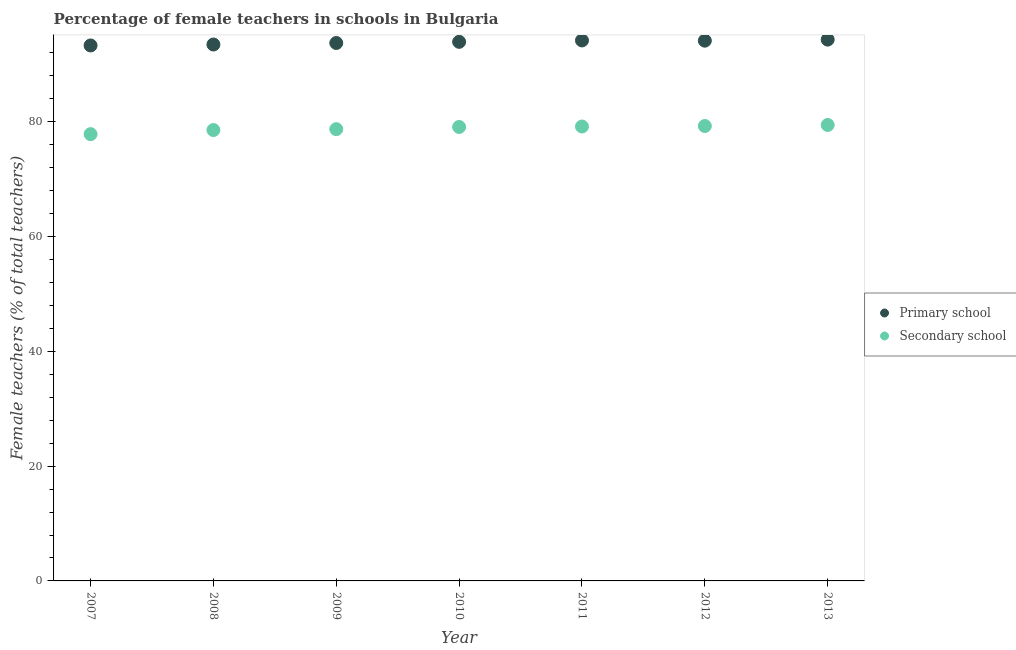How many different coloured dotlines are there?
Give a very brief answer. 2. Is the number of dotlines equal to the number of legend labels?
Provide a succinct answer. Yes. What is the percentage of female teachers in primary schools in 2009?
Keep it short and to the point. 93.73. Across all years, what is the maximum percentage of female teachers in secondary schools?
Give a very brief answer. 79.45. Across all years, what is the minimum percentage of female teachers in secondary schools?
Offer a terse response. 77.85. In which year was the percentage of female teachers in primary schools maximum?
Keep it short and to the point. 2013. In which year was the percentage of female teachers in primary schools minimum?
Give a very brief answer. 2007. What is the total percentage of female teachers in secondary schools in the graph?
Offer a very short reply. 552.12. What is the difference between the percentage of female teachers in primary schools in 2008 and that in 2010?
Offer a terse response. -0.47. What is the difference between the percentage of female teachers in primary schools in 2011 and the percentage of female teachers in secondary schools in 2009?
Your answer should be compact. 15.46. What is the average percentage of female teachers in secondary schools per year?
Make the answer very short. 78.87. In the year 2013, what is the difference between the percentage of female teachers in secondary schools and percentage of female teachers in primary schools?
Your response must be concise. -14.87. What is the ratio of the percentage of female teachers in primary schools in 2007 to that in 2010?
Your response must be concise. 0.99. What is the difference between the highest and the second highest percentage of female teachers in primary schools?
Offer a terse response. 0.15. What is the difference between the highest and the lowest percentage of female teachers in primary schools?
Make the answer very short. 1.02. In how many years, is the percentage of female teachers in secondary schools greater than the average percentage of female teachers in secondary schools taken over all years?
Keep it short and to the point. 4. Is the sum of the percentage of female teachers in secondary schools in 2009 and 2012 greater than the maximum percentage of female teachers in primary schools across all years?
Your answer should be very brief. Yes. Does the graph contain any zero values?
Offer a very short reply. No. Where does the legend appear in the graph?
Ensure brevity in your answer.  Center right. How many legend labels are there?
Give a very brief answer. 2. How are the legend labels stacked?
Offer a very short reply. Vertical. What is the title of the graph?
Give a very brief answer. Percentage of female teachers in schools in Bulgaria. What is the label or title of the X-axis?
Ensure brevity in your answer.  Year. What is the label or title of the Y-axis?
Your answer should be compact. Female teachers (% of total teachers). What is the Female teachers (% of total teachers) of Primary school in 2007?
Your response must be concise. 93.3. What is the Female teachers (% of total teachers) in Secondary school in 2007?
Your answer should be very brief. 77.85. What is the Female teachers (% of total teachers) of Primary school in 2008?
Your answer should be very brief. 93.47. What is the Female teachers (% of total teachers) in Secondary school in 2008?
Give a very brief answer. 78.56. What is the Female teachers (% of total teachers) of Primary school in 2009?
Keep it short and to the point. 93.73. What is the Female teachers (% of total teachers) of Secondary school in 2009?
Offer a very short reply. 78.72. What is the Female teachers (% of total teachers) of Primary school in 2010?
Your response must be concise. 93.93. What is the Female teachers (% of total teachers) in Secondary school in 2010?
Offer a terse response. 79.1. What is the Female teachers (% of total teachers) of Primary school in 2011?
Provide a succinct answer. 94.17. What is the Female teachers (% of total teachers) in Secondary school in 2011?
Keep it short and to the point. 79.18. What is the Female teachers (% of total teachers) of Primary school in 2012?
Your answer should be very brief. 94.13. What is the Female teachers (% of total teachers) in Secondary school in 2012?
Offer a terse response. 79.27. What is the Female teachers (% of total teachers) of Primary school in 2013?
Your answer should be compact. 94.32. What is the Female teachers (% of total teachers) in Secondary school in 2013?
Your answer should be very brief. 79.45. Across all years, what is the maximum Female teachers (% of total teachers) of Primary school?
Offer a terse response. 94.32. Across all years, what is the maximum Female teachers (% of total teachers) of Secondary school?
Keep it short and to the point. 79.45. Across all years, what is the minimum Female teachers (% of total teachers) in Primary school?
Your answer should be compact. 93.3. Across all years, what is the minimum Female teachers (% of total teachers) of Secondary school?
Provide a succinct answer. 77.85. What is the total Female teachers (% of total teachers) in Primary school in the graph?
Your answer should be very brief. 657.06. What is the total Female teachers (% of total teachers) of Secondary school in the graph?
Make the answer very short. 552.12. What is the difference between the Female teachers (% of total teachers) of Secondary school in 2007 and that in 2008?
Offer a terse response. -0.72. What is the difference between the Female teachers (% of total teachers) in Primary school in 2007 and that in 2009?
Provide a succinct answer. -0.43. What is the difference between the Female teachers (% of total teachers) in Secondary school in 2007 and that in 2009?
Your response must be concise. -0.87. What is the difference between the Female teachers (% of total teachers) of Primary school in 2007 and that in 2010?
Give a very brief answer. -0.63. What is the difference between the Female teachers (% of total teachers) in Secondary school in 2007 and that in 2010?
Offer a terse response. -1.25. What is the difference between the Female teachers (% of total teachers) in Primary school in 2007 and that in 2011?
Ensure brevity in your answer.  -0.87. What is the difference between the Female teachers (% of total teachers) of Secondary school in 2007 and that in 2011?
Your answer should be very brief. -1.33. What is the difference between the Female teachers (% of total teachers) of Primary school in 2007 and that in 2012?
Your answer should be compact. -0.83. What is the difference between the Female teachers (% of total teachers) of Secondary school in 2007 and that in 2012?
Offer a very short reply. -1.42. What is the difference between the Female teachers (% of total teachers) of Primary school in 2007 and that in 2013?
Make the answer very short. -1.02. What is the difference between the Female teachers (% of total teachers) of Secondary school in 2007 and that in 2013?
Keep it short and to the point. -1.6. What is the difference between the Female teachers (% of total teachers) of Primary school in 2008 and that in 2009?
Provide a succinct answer. -0.27. What is the difference between the Female teachers (% of total teachers) in Secondary school in 2008 and that in 2009?
Give a very brief answer. -0.16. What is the difference between the Female teachers (% of total teachers) of Primary school in 2008 and that in 2010?
Offer a very short reply. -0.47. What is the difference between the Female teachers (% of total teachers) in Secondary school in 2008 and that in 2010?
Provide a succinct answer. -0.54. What is the difference between the Female teachers (% of total teachers) of Primary school in 2008 and that in 2011?
Offer a very short reply. -0.71. What is the difference between the Female teachers (% of total teachers) of Secondary school in 2008 and that in 2011?
Give a very brief answer. -0.62. What is the difference between the Female teachers (% of total teachers) of Primary school in 2008 and that in 2012?
Give a very brief answer. -0.67. What is the difference between the Female teachers (% of total teachers) in Secondary school in 2008 and that in 2012?
Your answer should be very brief. -0.7. What is the difference between the Female teachers (% of total teachers) in Primary school in 2008 and that in 2013?
Your answer should be compact. -0.86. What is the difference between the Female teachers (% of total teachers) in Secondary school in 2008 and that in 2013?
Offer a very short reply. -0.88. What is the difference between the Female teachers (% of total teachers) of Primary school in 2009 and that in 2010?
Your answer should be very brief. -0.2. What is the difference between the Female teachers (% of total teachers) in Secondary school in 2009 and that in 2010?
Offer a very short reply. -0.38. What is the difference between the Female teachers (% of total teachers) in Primary school in 2009 and that in 2011?
Offer a very short reply. -0.44. What is the difference between the Female teachers (% of total teachers) in Secondary school in 2009 and that in 2011?
Provide a short and direct response. -0.46. What is the difference between the Female teachers (% of total teachers) in Primary school in 2009 and that in 2012?
Provide a succinct answer. -0.4. What is the difference between the Female teachers (% of total teachers) of Secondary school in 2009 and that in 2012?
Make the answer very short. -0.55. What is the difference between the Female teachers (% of total teachers) in Primary school in 2009 and that in 2013?
Offer a very short reply. -0.59. What is the difference between the Female teachers (% of total teachers) in Secondary school in 2009 and that in 2013?
Your answer should be compact. -0.73. What is the difference between the Female teachers (% of total teachers) in Primary school in 2010 and that in 2011?
Provide a succinct answer. -0.24. What is the difference between the Female teachers (% of total teachers) of Secondary school in 2010 and that in 2011?
Make the answer very short. -0.08. What is the difference between the Female teachers (% of total teachers) in Secondary school in 2010 and that in 2012?
Make the answer very short. -0.17. What is the difference between the Female teachers (% of total teachers) in Primary school in 2010 and that in 2013?
Your answer should be very brief. -0.39. What is the difference between the Female teachers (% of total teachers) in Secondary school in 2010 and that in 2013?
Your response must be concise. -0.35. What is the difference between the Female teachers (% of total teachers) in Primary school in 2011 and that in 2012?
Ensure brevity in your answer.  0.04. What is the difference between the Female teachers (% of total teachers) of Secondary school in 2011 and that in 2012?
Your answer should be very brief. -0.09. What is the difference between the Female teachers (% of total teachers) in Primary school in 2011 and that in 2013?
Ensure brevity in your answer.  -0.15. What is the difference between the Female teachers (% of total teachers) in Secondary school in 2011 and that in 2013?
Keep it short and to the point. -0.27. What is the difference between the Female teachers (% of total teachers) in Primary school in 2012 and that in 2013?
Give a very brief answer. -0.19. What is the difference between the Female teachers (% of total teachers) in Secondary school in 2012 and that in 2013?
Offer a very short reply. -0.18. What is the difference between the Female teachers (% of total teachers) in Primary school in 2007 and the Female teachers (% of total teachers) in Secondary school in 2008?
Offer a very short reply. 14.74. What is the difference between the Female teachers (% of total teachers) of Primary school in 2007 and the Female teachers (% of total teachers) of Secondary school in 2009?
Make the answer very short. 14.58. What is the difference between the Female teachers (% of total teachers) in Primary school in 2007 and the Female teachers (% of total teachers) in Secondary school in 2010?
Your answer should be very brief. 14.2. What is the difference between the Female teachers (% of total teachers) of Primary school in 2007 and the Female teachers (% of total teachers) of Secondary school in 2011?
Ensure brevity in your answer.  14.12. What is the difference between the Female teachers (% of total teachers) in Primary school in 2007 and the Female teachers (% of total teachers) in Secondary school in 2012?
Your response must be concise. 14.03. What is the difference between the Female teachers (% of total teachers) in Primary school in 2007 and the Female teachers (% of total teachers) in Secondary school in 2013?
Your answer should be compact. 13.85. What is the difference between the Female teachers (% of total teachers) in Primary school in 2008 and the Female teachers (% of total teachers) in Secondary school in 2009?
Make the answer very short. 14.75. What is the difference between the Female teachers (% of total teachers) of Primary school in 2008 and the Female teachers (% of total teachers) of Secondary school in 2010?
Your response must be concise. 14.37. What is the difference between the Female teachers (% of total teachers) of Primary school in 2008 and the Female teachers (% of total teachers) of Secondary school in 2011?
Offer a terse response. 14.29. What is the difference between the Female teachers (% of total teachers) of Primary school in 2008 and the Female teachers (% of total teachers) of Secondary school in 2012?
Ensure brevity in your answer.  14.2. What is the difference between the Female teachers (% of total teachers) of Primary school in 2008 and the Female teachers (% of total teachers) of Secondary school in 2013?
Offer a terse response. 14.02. What is the difference between the Female teachers (% of total teachers) in Primary school in 2009 and the Female teachers (% of total teachers) in Secondary school in 2010?
Provide a short and direct response. 14.63. What is the difference between the Female teachers (% of total teachers) of Primary school in 2009 and the Female teachers (% of total teachers) of Secondary school in 2011?
Give a very brief answer. 14.55. What is the difference between the Female teachers (% of total teachers) in Primary school in 2009 and the Female teachers (% of total teachers) in Secondary school in 2012?
Your answer should be compact. 14.47. What is the difference between the Female teachers (% of total teachers) in Primary school in 2009 and the Female teachers (% of total teachers) in Secondary school in 2013?
Give a very brief answer. 14.28. What is the difference between the Female teachers (% of total teachers) in Primary school in 2010 and the Female teachers (% of total teachers) in Secondary school in 2011?
Ensure brevity in your answer.  14.76. What is the difference between the Female teachers (% of total teachers) in Primary school in 2010 and the Female teachers (% of total teachers) in Secondary school in 2012?
Your answer should be very brief. 14.67. What is the difference between the Female teachers (% of total teachers) in Primary school in 2010 and the Female teachers (% of total teachers) in Secondary school in 2013?
Offer a terse response. 14.49. What is the difference between the Female teachers (% of total teachers) of Primary school in 2011 and the Female teachers (% of total teachers) of Secondary school in 2012?
Keep it short and to the point. 14.91. What is the difference between the Female teachers (% of total teachers) of Primary school in 2011 and the Female teachers (% of total teachers) of Secondary school in 2013?
Your answer should be compact. 14.73. What is the difference between the Female teachers (% of total teachers) of Primary school in 2012 and the Female teachers (% of total teachers) of Secondary school in 2013?
Provide a short and direct response. 14.69. What is the average Female teachers (% of total teachers) of Primary school per year?
Offer a terse response. 93.87. What is the average Female teachers (% of total teachers) of Secondary school per year?
Ensure brevity in your answer.  78.87. In the year 2007, what is the difference between the Female teachers (% of total teachers) of Primary school and Female teachers (% of total teachers) of Secondary school?
Ensure brevity in your answer.  15.45. In the year 2008, what is the difference between the Female teachers (% of total teachers) of Primary school and Female teachers (% of total teachers) of Secondary school?
Offer a very short reply. 14.9. In the year 2009, what is the difference between the Female teachers (% of total teachers) in Primary school and Female teachers (% of total teachers) in Secondary school?
Your response must be concise. 15.01. In the year 2010, what is the difference between the Female teachers (% of total teachers) in Primary school and Female teachers (% of total teachers) in Secondary school?
Provide a short and direct response. 14.83. In the year 2011, what is the difference between the Female teachers (% of total teachers) of Primary school and Female teachers (% of total teachers) of Secondary school?
Give a very brief answer. 15. In the year 2012, what is the difference between the Female teachers (% of total teachers) of Primary school and Female teachers (% of total teachers) of Secondary school?
Provide a short and direct response. 14.87. In the year 2013, what is the difference between the Female teachers (% of total teachers) of Primary school and Female teachers (% of total teachers) of Secondary school?
Give a very brief answer. 14.87. What is the ratio of the Female teachers (% of total teachers) in Primary school in 2007 to that in 2008?
Your answer should be very brief. 1. What is the ratio of the Female teachers (% of total teachers) of Secondary school in 2007 to that in 2008?
Your answer should be compact. 0.99. What is the ratio of the Female teachers (% of total teachers) of Primary school in 2007 to that in 2009?
Keep it short and to the point. 1. What is the ratio of the Female teachers (% of total teachers) in Secondary school in 2007 to that in 2009?
Provide a succinct answer. 0.99. What is the ratio of the Female teachers (% of total teachers) in Secondary school in 2007 to that in 2010?
Offer a terse response. 0.98. What is the ratio of the Female teachers (% of total teachers) of Primary school in 2007 to that in 2011?
Your response must be concise. 0.99. What is the ratio of the Female teachers (% of total teachers) in Secondary school in 2007 to that in 2011?
Offer a terse response. 0.98. What is the ratio of the Female teachers (% of total teachers) in Primary school in 2007 to that in 2012?
Your answer should be very brief. 0.99. What is the ratio of the Female teachers (% of total teachers) in Secondary school in 2007 to that in 2012?
Offer a terse response. 0.98. What is the ratio of the Female teachers (% of total teachers) in Secondary school in 2007 to that in 2013?
Ensure brevity in your answer.  0.98. What is the ratio of the Female teachers (% of total teachers) of Primary school in 2008 to that in 2012?
Your response must be concise. 0.99. What is the ratio of the Female teachers (% of total teachers) of Primary school in 2008 to that in 2013?
Make the answer very short. 0.99. What is the ratio of the Female teachers (% of total teachers) in Secondary school in 2008 to that in 2013?
Give a very brief answer. 0.99. What is the ratio of the Female teachers (% of total teachers) of Primary school in 2009 to that in 2010?
Your answer should be compact. 1. What is the ratio of the Female teachers (% of total teachers) of Secondary school in 2009 to that in 2010?
Your response must be concise. 1. What is the ratio of the Female teachers (% of total teachers) in Secondary school in 2009 to that in 2011?
Provide a succinct answer. 0.99. What is the ratio of the Female teachers (% of total teachers) of Secondary school in 2010 to that in 2012?
Your response must be concise. 1. What is the ratio of the Female teachers (% of total teachers) of Secondary school in 2011 to that in 2012?
Give a very brief answer. 1. What is the ratio of the Female teachers (% of total teachers) of Secondary school in 2011 to that in 2013?
Provide a succinct answer. 1. What is the difference between the highest and the second highest Female teachers (% of total teachers) of Primary school?
Provide a succinct answer. 0.15. What is the difference between the highest and the second highest Female teachers (% of total teachers) in Secondary school?
Provide a succinct answer. 0.18. What is the difference between the highest and the lowest Female teachers (% of total teachers) of Primary school?
Your response must be concise. 1.02. What is the difference between the highest and the lowest Female teachers (% of total teachers) in Secondary school?
Make the answer very short. 1.6. 